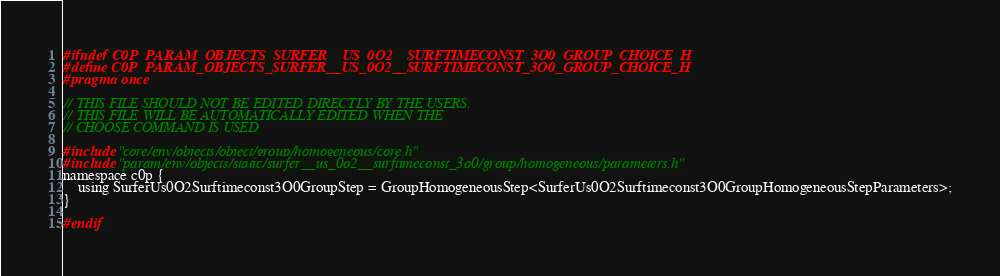<code> <loc_0><loc_0><loc_500><loc_500><_C_>#ifndef C0P_PARAM_OBJECTS_SURFER__US_0O2__SURFTIMECONST_3O0_GROUP_CHOICE_H
#define C0P_PARAM_OBJECTS_SURFER__US_0O2__SURFTIMECONST_3O0_GROUP_CHOICE_H
#pragma once

// THIS FILE SHOULD NOT BE EDITED DIRECTLY BY THE USERS.
// THIS FILE WILL BE AUTOMATICALLY EDITED WHEN THE
// CHOOSE COMMAND IS USED

#include "core/env/objects/object/group/homogeneous/core.h"
#include "param/env/objects/static/surfer__us_0o2__surftimeconst_3o0/group/homogeneous/parameters.h"
namespace c0p {
    using SurferUs0O2Surftimeconst3O0GroupStep = GroupHomogeneousStep<SurferUs0O2Surftimeconst3O0GroupHomogeneousStepParameters>;
}

#endif
</code> 